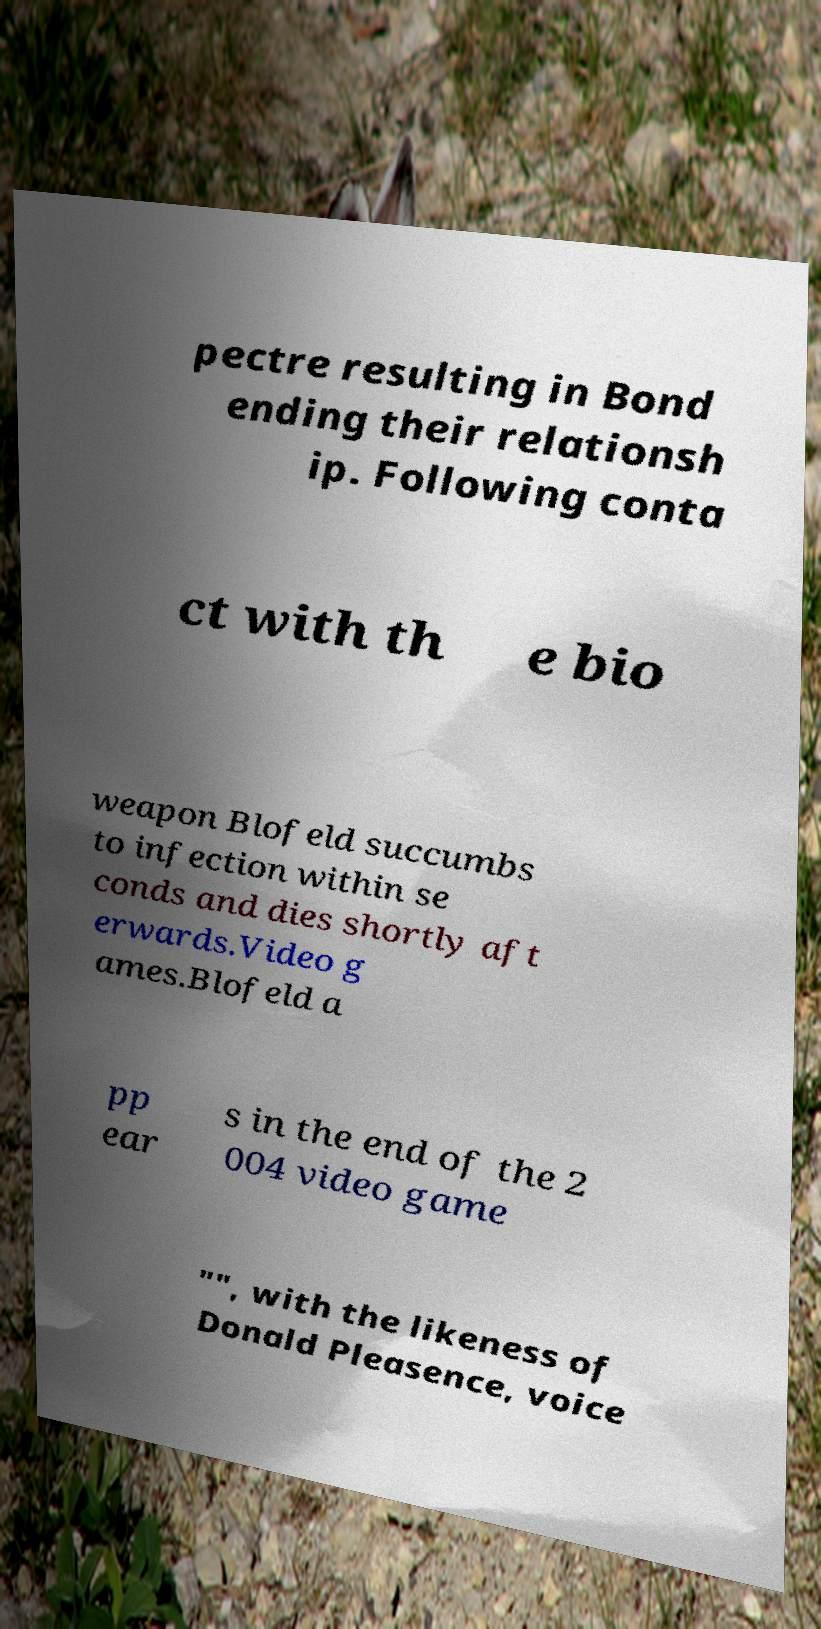Can you accurately transcribe the text from the provided image for me? pectre resulting in Bond ending their relationsh ip. Following conta ct with th e bio weapon Blofeld succumbs to infection within se conds and dies shortly aft erwards.Video g ames.Blofeld a pp ear s in the end of the 2 004 video game "", with the likeness of Donald Pleasence, voice 